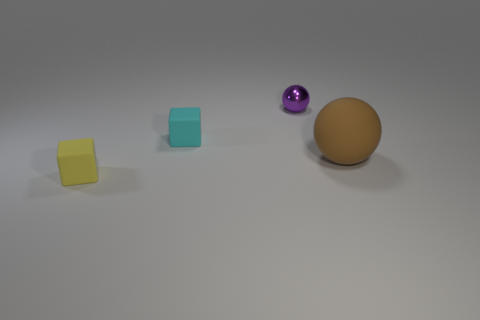Is there anything else that has the same size as the brown rubber sphere?
Your answer should be very brief. No. Are there any purple cubes of the same size as the metallic ball?
Offer a very short reply. No. There is a small cyan thing that is the same shape as the yellow matte object; what is it made of?
Ensure brevity in your answer.  Rubber. There is a cyan object that is the same size as the yellow block; what shape is it?
Provide a short and direct response. Cube. Is there a tiny purple object that has the same shape as the brown object?
Provide a short and direct response. Yes. What shape is the matte thing to the right of the small object to the right of the cyan rubber object?
Keep it short and to the point. Sphere. What is the shape of the small purple thing?
Provide a short and direct response. Sphere. There is a ball that is to the right of the sphere that is behind the ball that is to the right of the purple thing; what is it made of?
Make the answer very short. Rubber. How many other things are there of the same material as the tiny ball?
Your response must be concise. 0. There is a yellow block that is in front of the brown rubber thing; what number of small cyan blocks are to the right of it?
Provide a succinct answer. 1. 